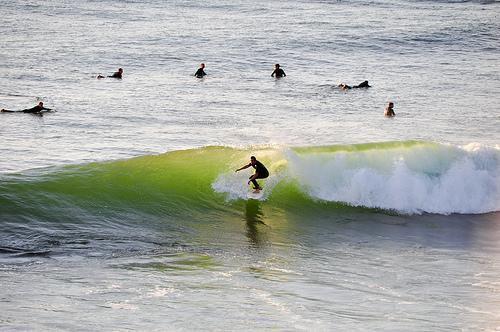How many people are there?
Give a very brief answer. 7. 